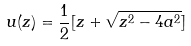Convert formula to latex. <formula><loc_0><loc_0><loc_500><loc_500>u ( z ) = { \frac { 1 } { 2 } } [ z + \sqrt { z ^ { 2 } - 4 a ^ { 2 } } ]</formula> 